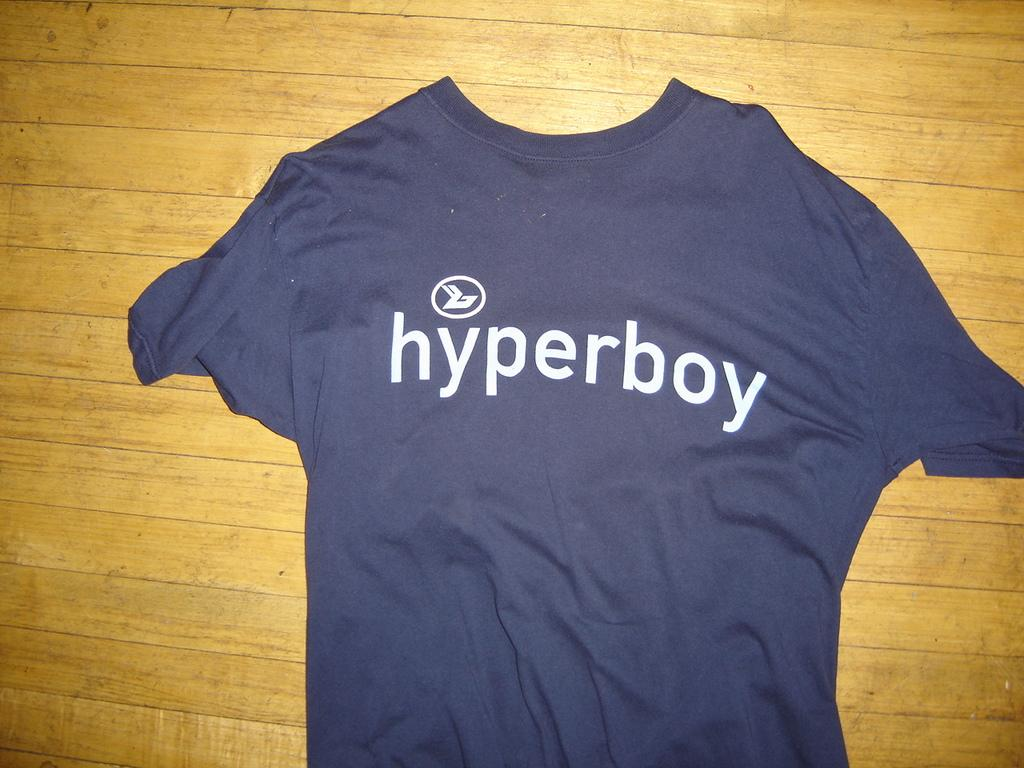<image>
Give a short and clear explanation of the subsequent image. a blue t-shirt with Hyperboy and logo laying on the floor 